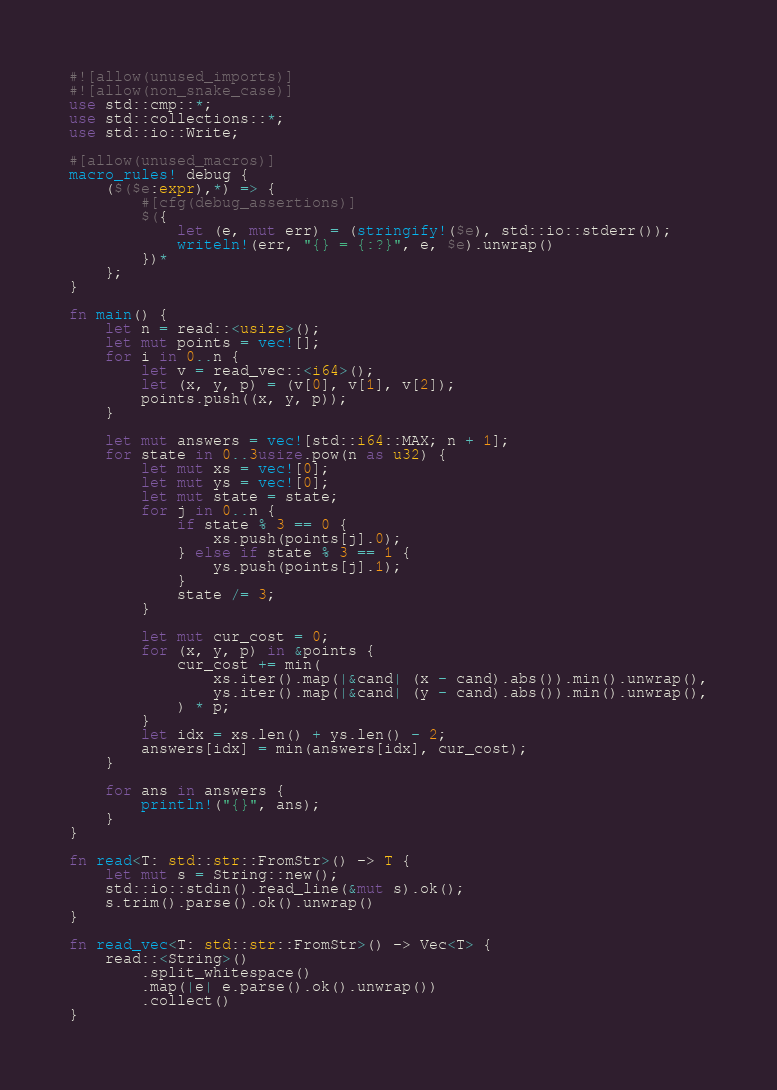<code> <loc_0><loc_0><loc_500><loc_500><_Rust_>#![allow(unused_imports)]
#![allow(non_snake_case)]
use std::cmp::*;
use std::collections::*;
use std::io::Write;

#[allow(unused_macros)]
macro_rules! debug {
    ($($e:expr),*) => {
        #[cfg(debug_assertions)]
        $({
            let (e, mut err) = (stringify!($e), std::io::stderr());
            writeln!(err, "{} = {:?}", e, $e).unwrap()
        })*
    };
}

fn main() {
    let n = read::<usize>();
    let mut points = vec![];
    for i in 0..n {
        let v = read_vec::<i64>();
        let (x, y, p) = (v[0], v[1], v[2]);
        points.push((x, y, p));
    }

    let mut answers = vec![std::i64::MAX; n + 1];
    for state in 0..3usize.pow(n as u32) {
        let mut xs = vec![0];
        let mut ys = vec![0];
        let mut state = state;
        for j in 0..n {
            if state % 3 == 0 {
                xs.push(points[j].0);
            } else if state % 3 == 1 {
                ys.push(points[j].1);
            }
            state /= 3;
        }

        let mut cur_cost = 0;
        for (x, y, p) in &points {
            cur_cost += min(
                xs.iter().map(|&cand| (x - cand).abs()).min().unwrap(),
                ys.iter().map(|&cand| (y - cand).abs()).min().unwrap(),
            ) * p;
        }
        let idx = xs.len() + ys.len() - 2;
        answers[idx] = min(answers[idx], cur_cost);
    }

    for ans in answers {
        println!("{}", ans);
    }
}

fn read<T: std::str::FromStr>() -> T {
    let mut s = String::new();
    std::io::stdin().read_line(&mut s).ok();
    s.trim().parse().ok().unwrap()
}

fn read_vec<T: std::str::FromStr>() -> Vec<T> {
    read::<String>()
        .split_whitespace()
        .map(|e| e.parse().ok().unwrap())
        .collect()
}
</code> 